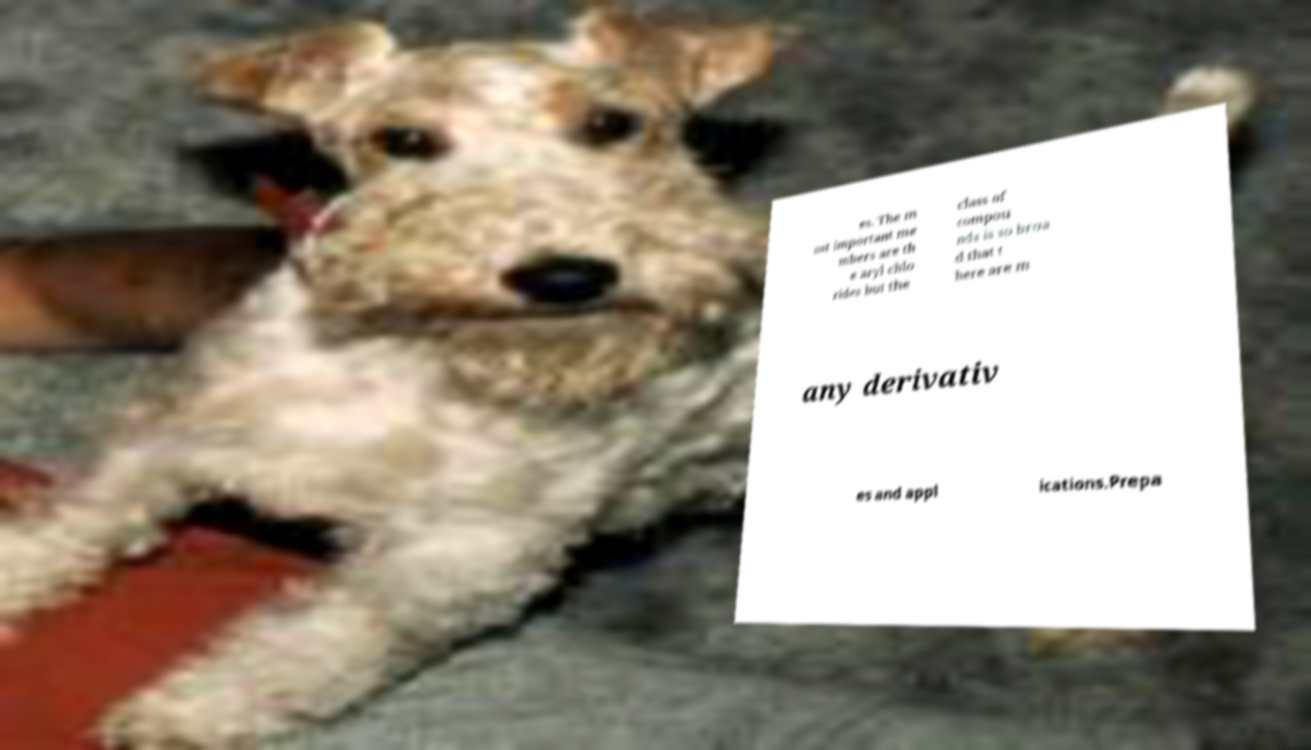What messages or text are displayed in this image? I need them in a readable, typed format. es. The m ost important me mbers are th e aryl chlo rides but the class of compou nds is so broa d that t here are m any derivativ es and appl ications.Prepa 